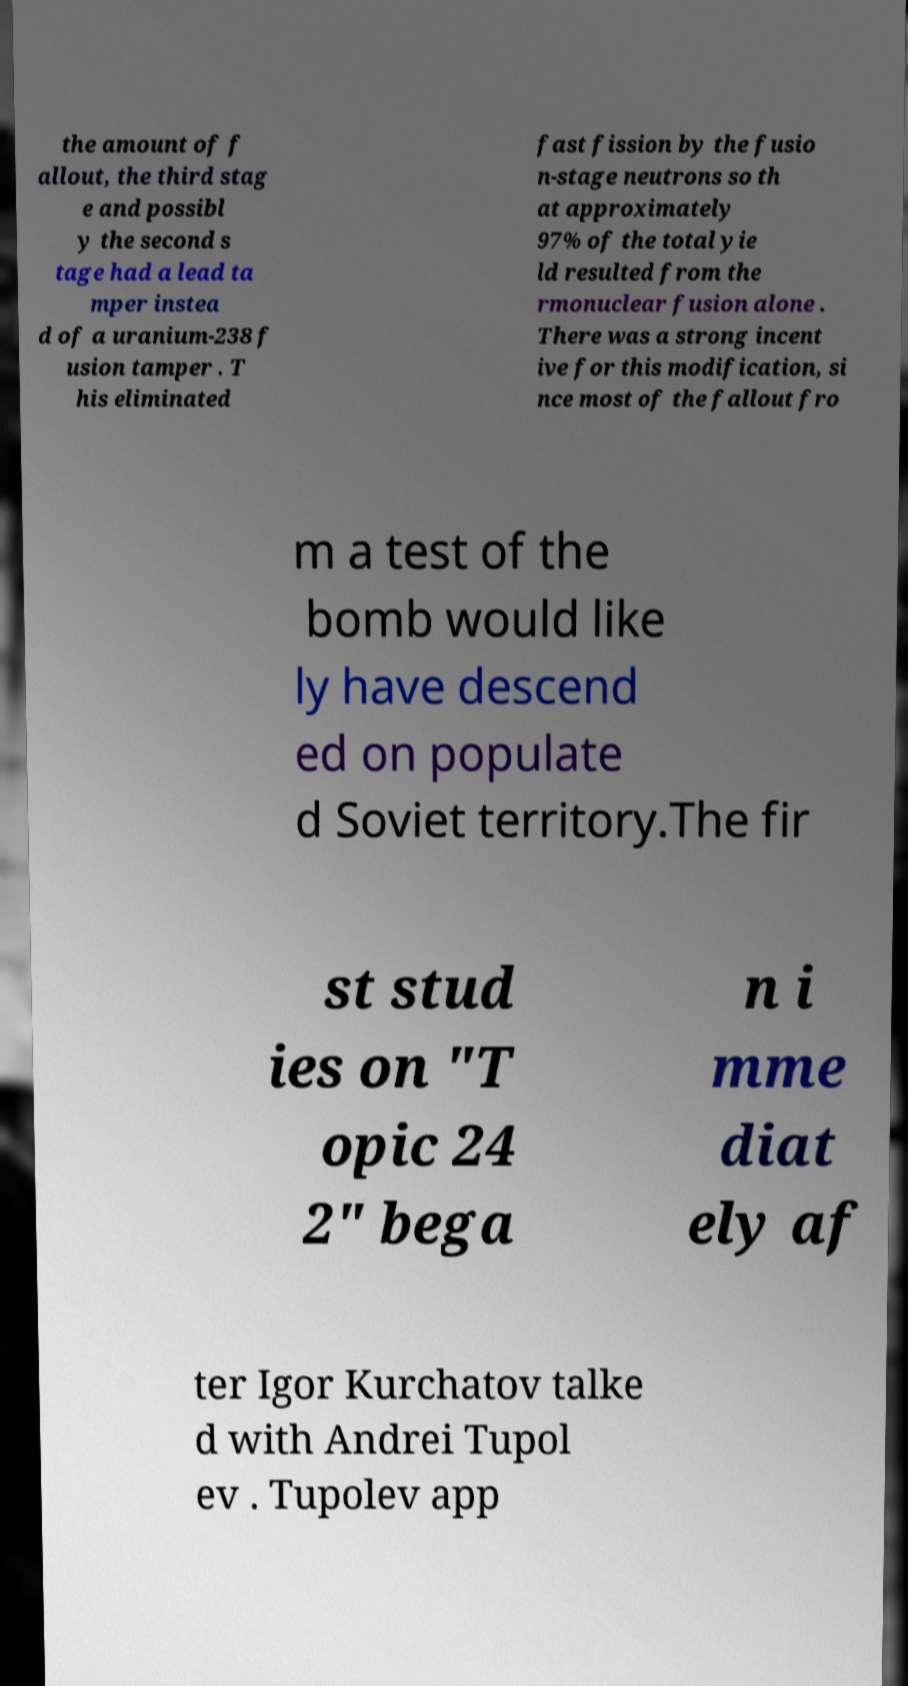I need the written content from this picture converted into text. Can you do that? the amount of f allout, the third stag e and possibl y the second s tage had a lead ta mper instea d of a uranium-238 f usion tamper . T his eliminated fast fission by the fusio n-stage neutrons so th at approximately 97% of the total yie ld resulted from the rmonuclear fusion alone . There was a strong incent ive for this modification, si nce most of the fallout fro m a test of the bomb would like ly have descend ed on populate d Soviet territory.The fir st stud ies on "T opic 24 2" bega n i mme diat ely af ter Igor Kurchatov talke d with Andrei Tupol ev . Tupolev app 